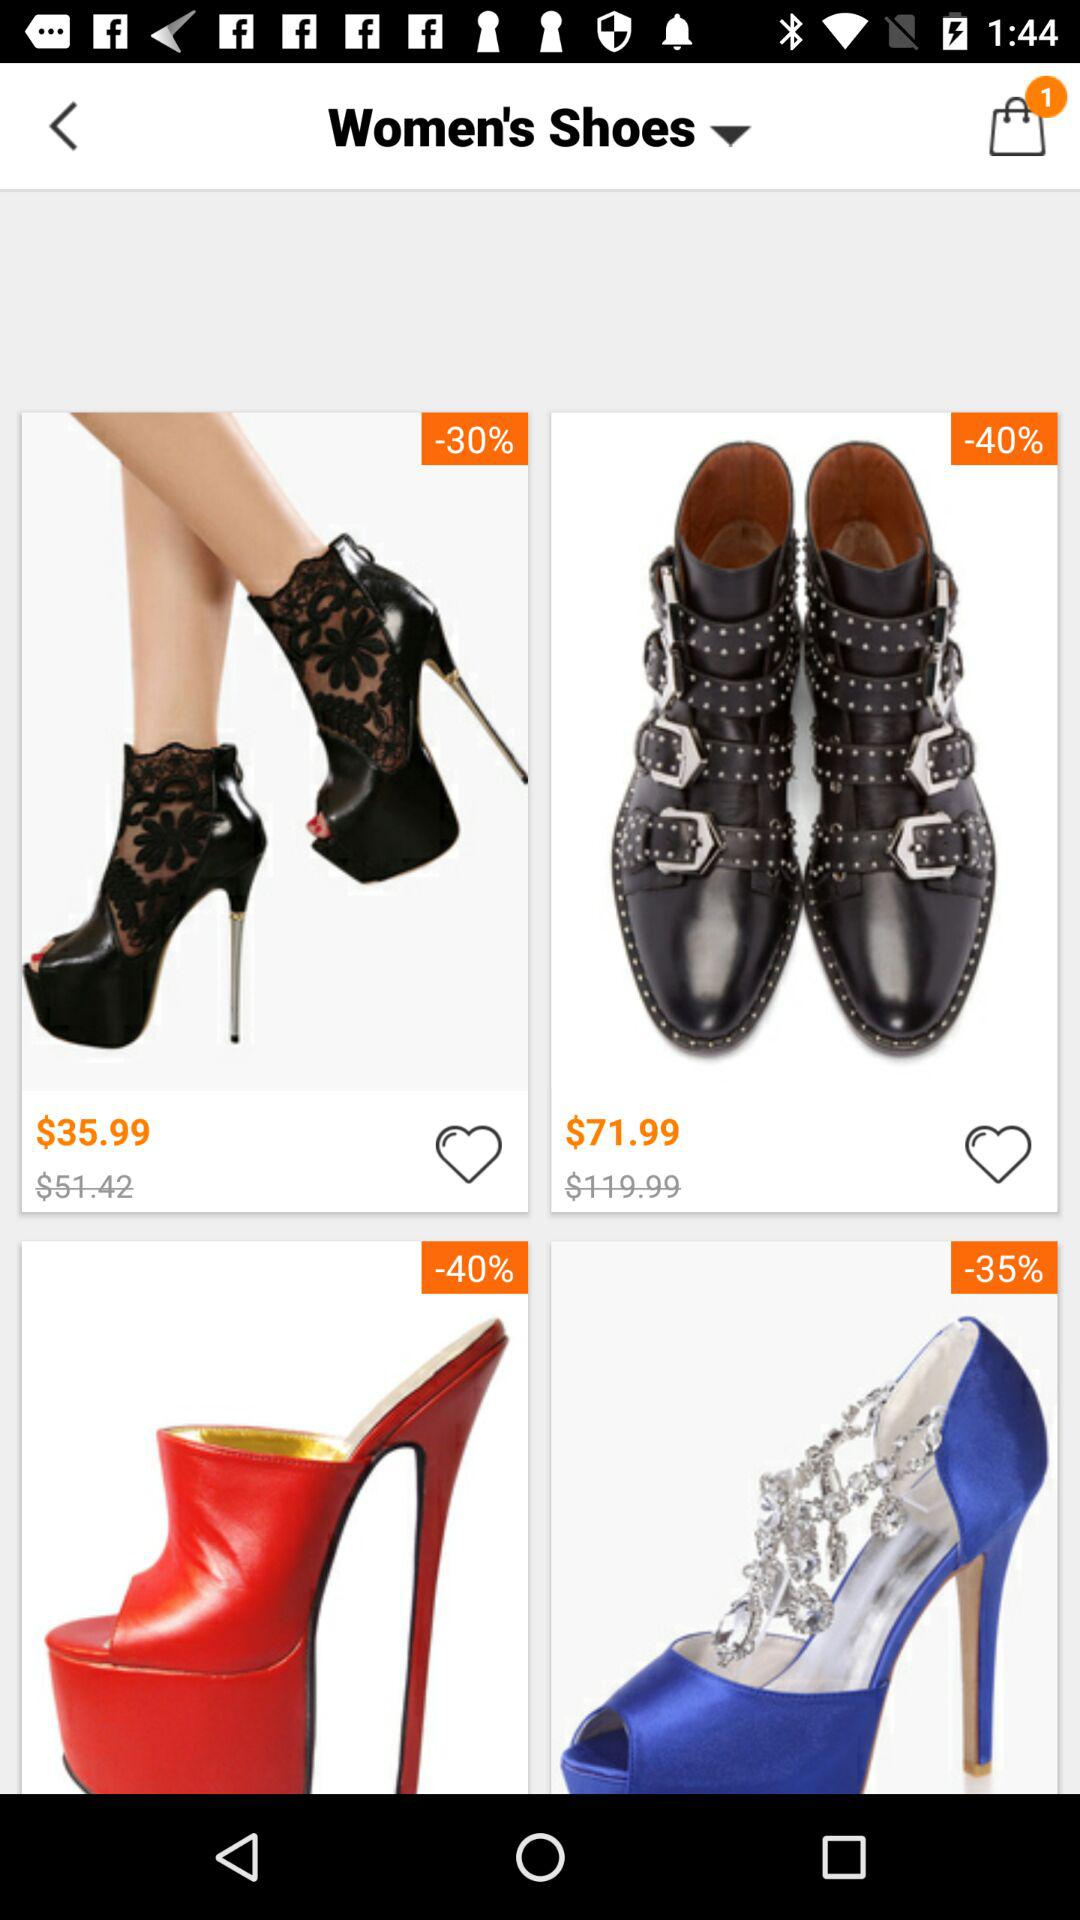How much is the discount on the red heels?
Answer the question using a single word or phrase. 40% 